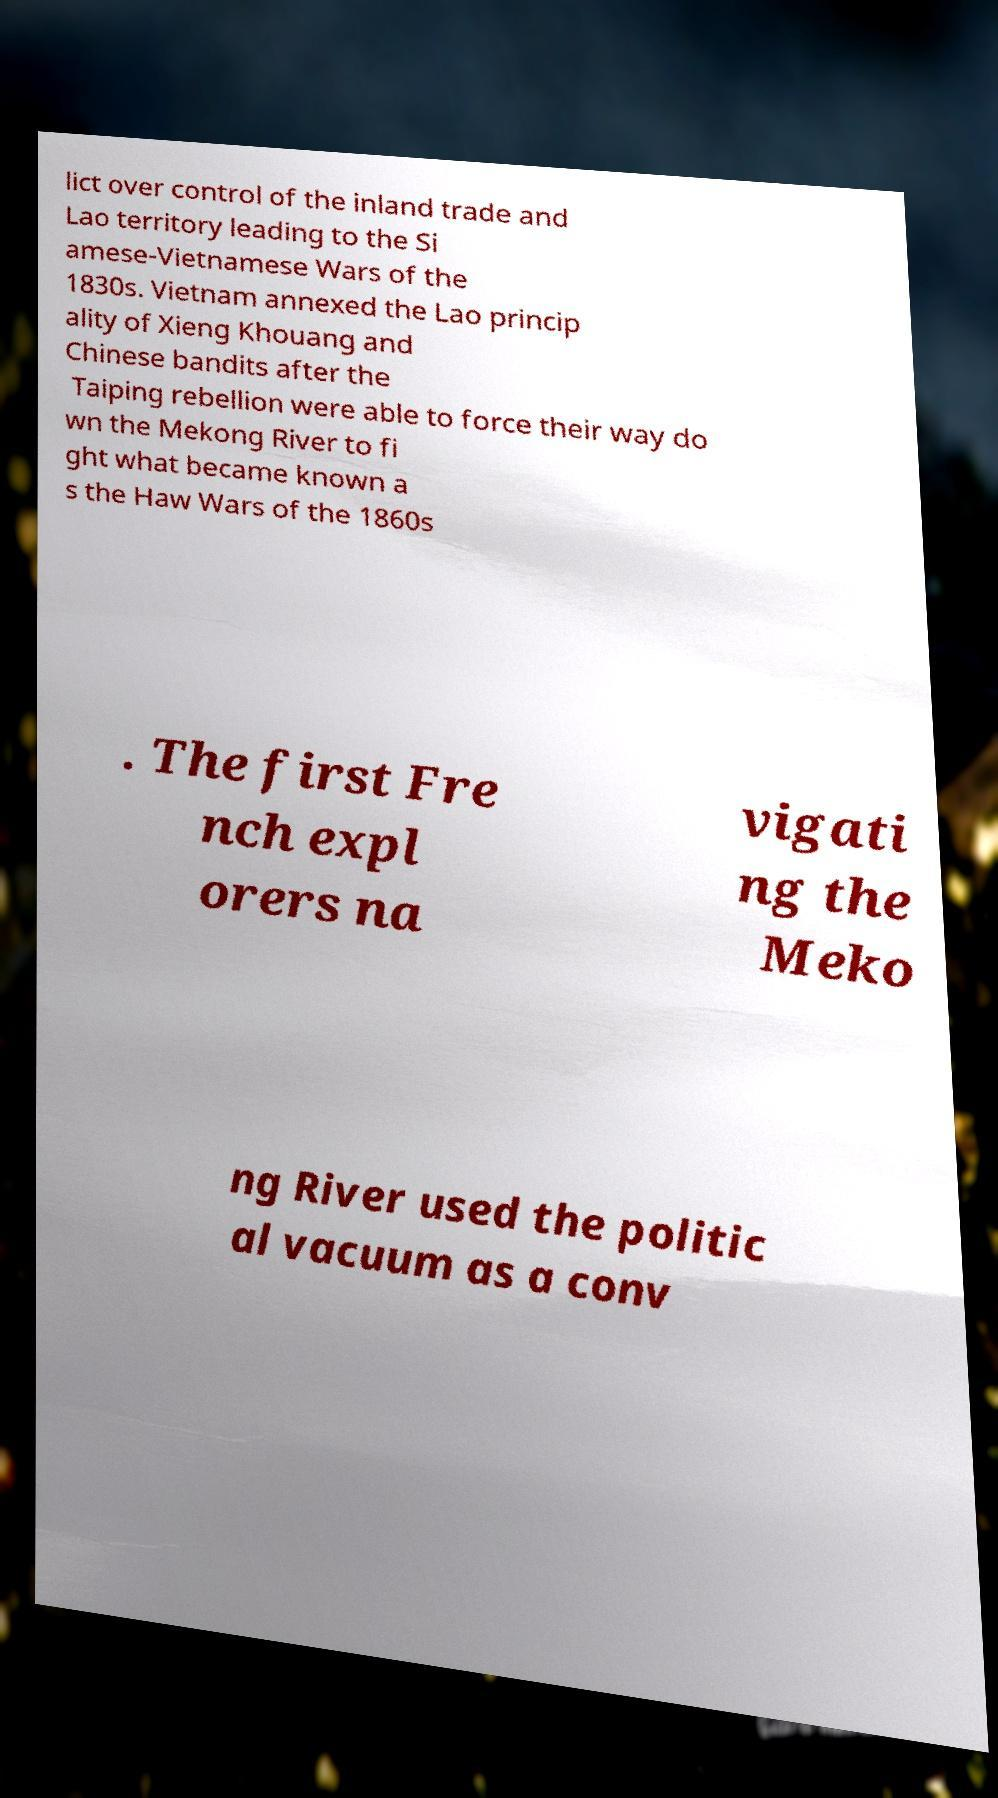For documentation purposes, I need the text within this image transcribed. Could you provide that? lict over control of the inland trade and Lao territory leading to the Si amese-Vietnamese Wars of the 1830s. Vietnam annexed the Lao princip ality of Xieng Khouang and Chinese bandits after the Taiping rebellion were able to force their way do wn the Mekong River to fi ght what became known a s the Haw Wars of the 1860s . The first Fre nch expl orers na vigati ng the Meko ng River used the politic al vacuum as a conv 